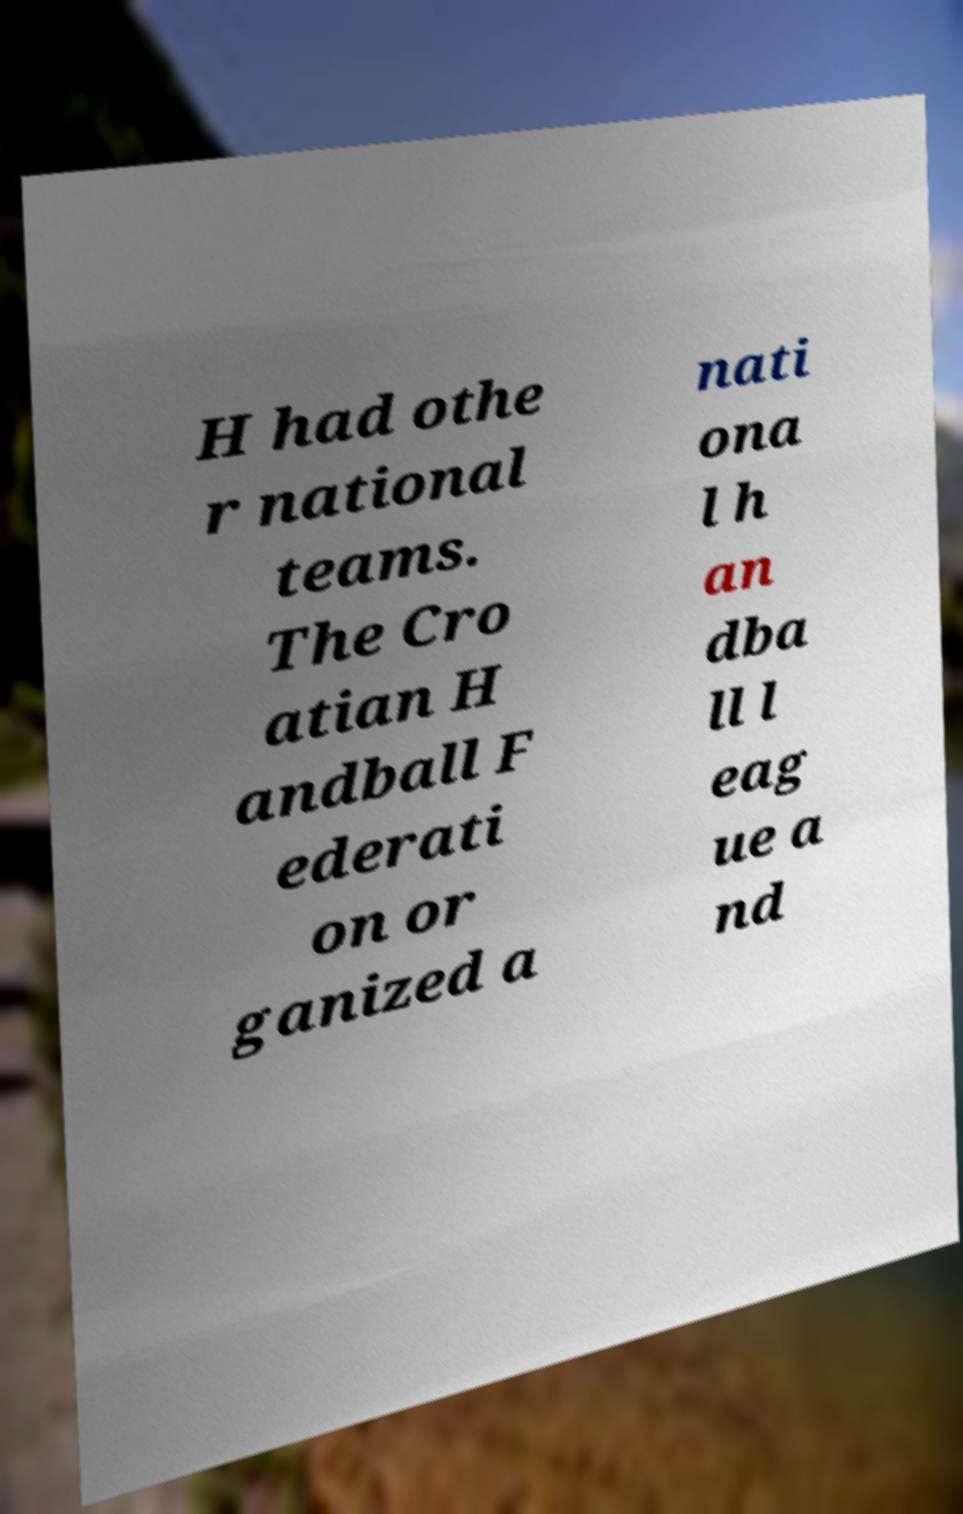There's text embedded in this image that I need extracted. Can you transcribe it verbatim? H had othe r national teams. The Cro atian H andball F ederati on or ganized a nati ona l h an dba ll l eag ue a nd 